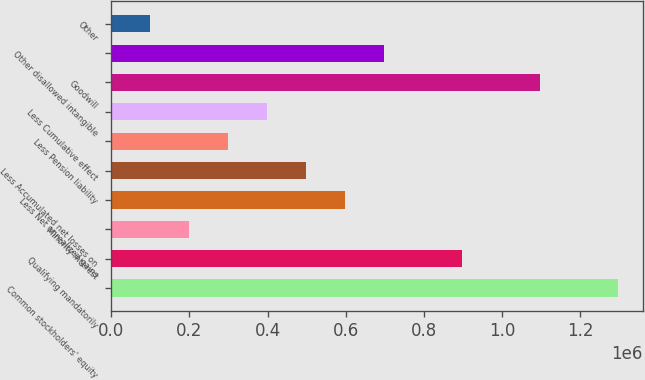Convert chart to OTSL. <chart><loc_0><loc_0><loc_500><loc_500><bar_chart><fcel>Common stockholders' equity<fcel>Qualifying mandatorily<fcel>Minority interest<fcel>Less Net unrealized gains<fcel>Less Accumulated net losses on<fcel>Less Pension liability<fcel>Less Cumulative effect<fcel>Goodwill<fcel>Other disallowed intangible<fcel>Other<nl><fcel>1.29511e+06<fcel>896627<fcel>199284<fcel>597765<fcel>498145<fcel>298904<fcel>398525<fcel>1.09587e+06<fcel>697386<fcel>99663.4<nl></chart> 